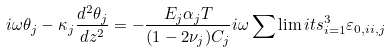<formula> <loc_0><loc_0><loc_500><loc_500>i \omega \theta _ { j } - \kappa _ { j } \frac { d ^ { 2 } \theta _ { j } } { d z ^ { 2 } } = - \frac { E _ { j } \alpha _ { j } T } { ( 1 - 2 \nu _ { j } ) C _ { j } } i \omega \sum \lim i t s _ { i = 1 } ^ { 3 } { \varepsilon _ { 0 , i i , j } }</formula> 